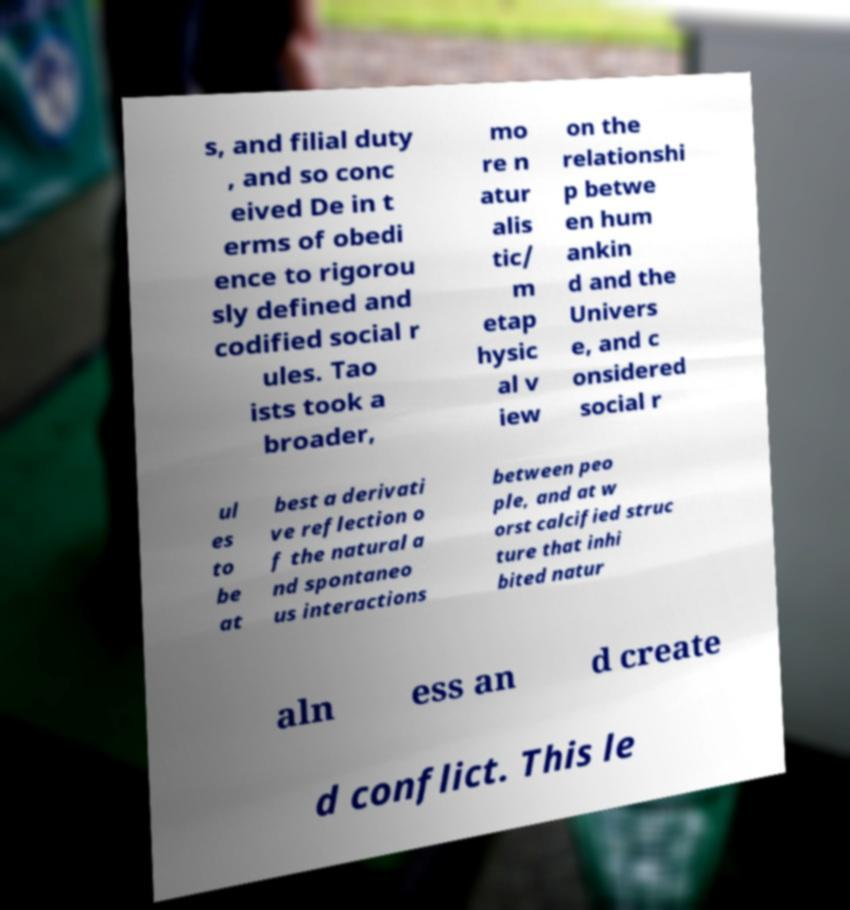Can you accurately transcribe the text from the provided image for me? s, and filial duty , and so conc eived De in t erms of obedi ence to rigorou sly defined and codified social r ules. Tao ists took a broader, mo re n atur alis tic/ m etap hysic al v iew on the relationshi p betwe en hum ankin d and the Univers e, and c onsidered social r ul es to be at best a derivati ve reflection o f the natural a nd spontaneo us interactions between peo ple, and at w orst calcified struc ture that inhi bited natur aln ess an d create d conflict. This le 